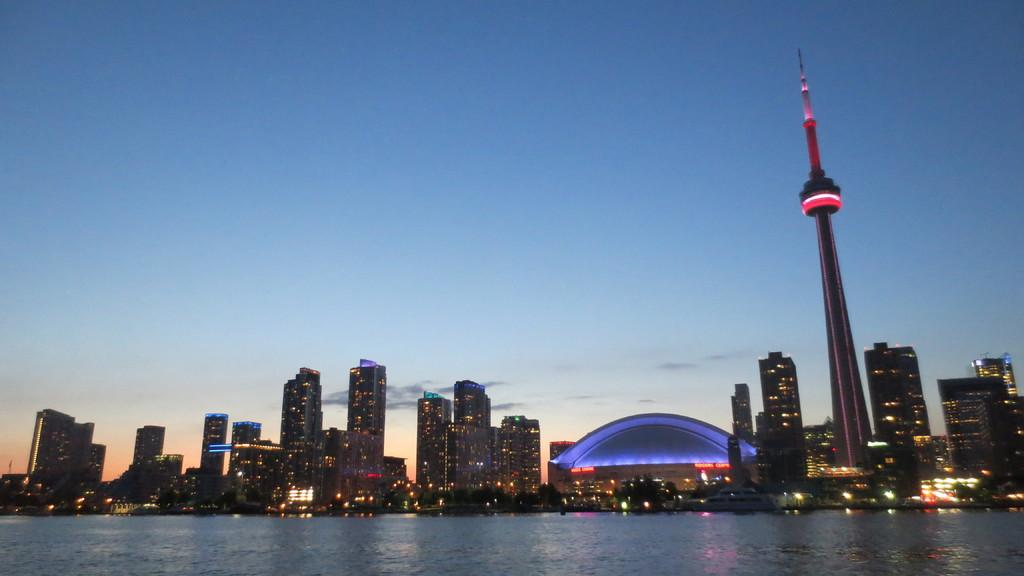What can be seen reflecting on the water in the image? There are reflections of lights on the water in the image. What type of structures can be seen in the background of the image? There are buildings and a tower in the background of the image. What else is visible in the image besides the water and buildings? There are lights visible in the image. What part of the natural environment is visible in the image? The sky is visible in the image. What type of discovery was made during the protest in the image? There is no protest or discovery present in the image; it features reflections of lights on water, buildings, a tower, lights, and the sky. What color are the jeans worn by the person in the image? There is no person wearing jeans present in the image. 